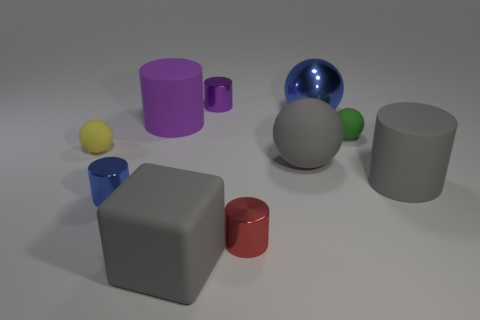Are there an equal number of red metallic cylinders that are left of the large purple thing and small yellow spheres that are behind the purple metal thing?
Keep it short and to the point. Yes. The large ball that is behind the purple thing left of the gray rubber block is made of what material?
Offer a very short reply. Metal. What number of objects are either large purple cylinders or metallic cylinders in front of the large gray ball?
Offer a terse response. 3. There is a ball that is the same material as the tiny red cylinder; what size is it?
Your response must be concise. Large. Are there more big rubber cylinders on the left side of the yellow object than large purple matte cylinders?
Give a very brief answer. No. There is a object that is both behind the big purple thing and to the right of the gray sphere; what size is it?
Make the answer very short. Large. There is a small yellow thing that is the same shape as the large blue metallic thing; what material is it?
Your answer should be very brief. Rubber. Are there an equal number of tiny gray balls and yellow rubber things?
Offer a very short reply. No. There is a blue sphere that is to the right of the matte block; is it the same size as the big purple rubber thing?
Make the answer very short. Yes. What is the color of the rubber object that is to the right of the big metallic sphere and left of the gray cylinder?
Provide a short and direct response. Green. 